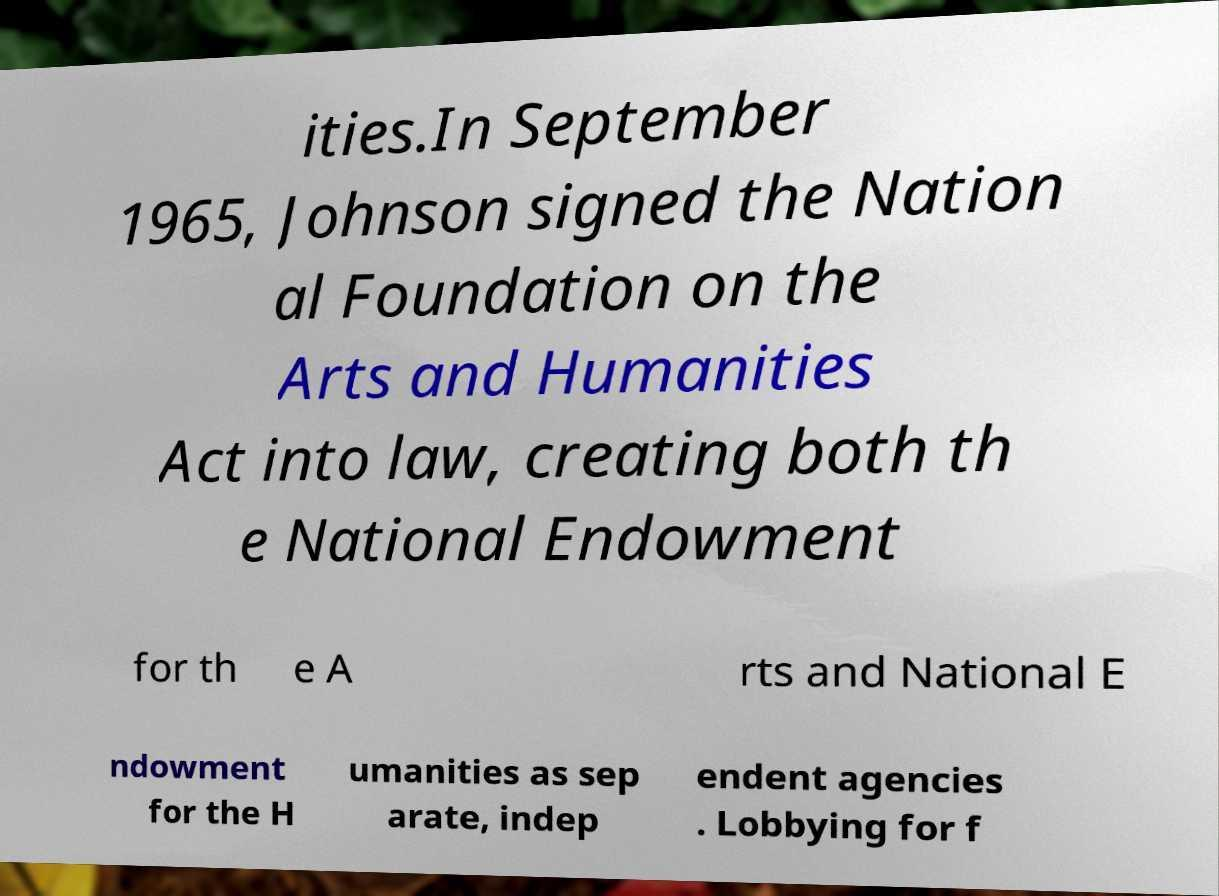What messages or text are displayed in this image? I need them in a readable, typed format. ities.In September 1965, Johnson signed the Nation al Foundation on the Arts and Humanities Act into law, creating both th e National Endowment for th e A rts and National E ndowment for the H umanities as sep arate, indep endent agencies . Lobbying for f 